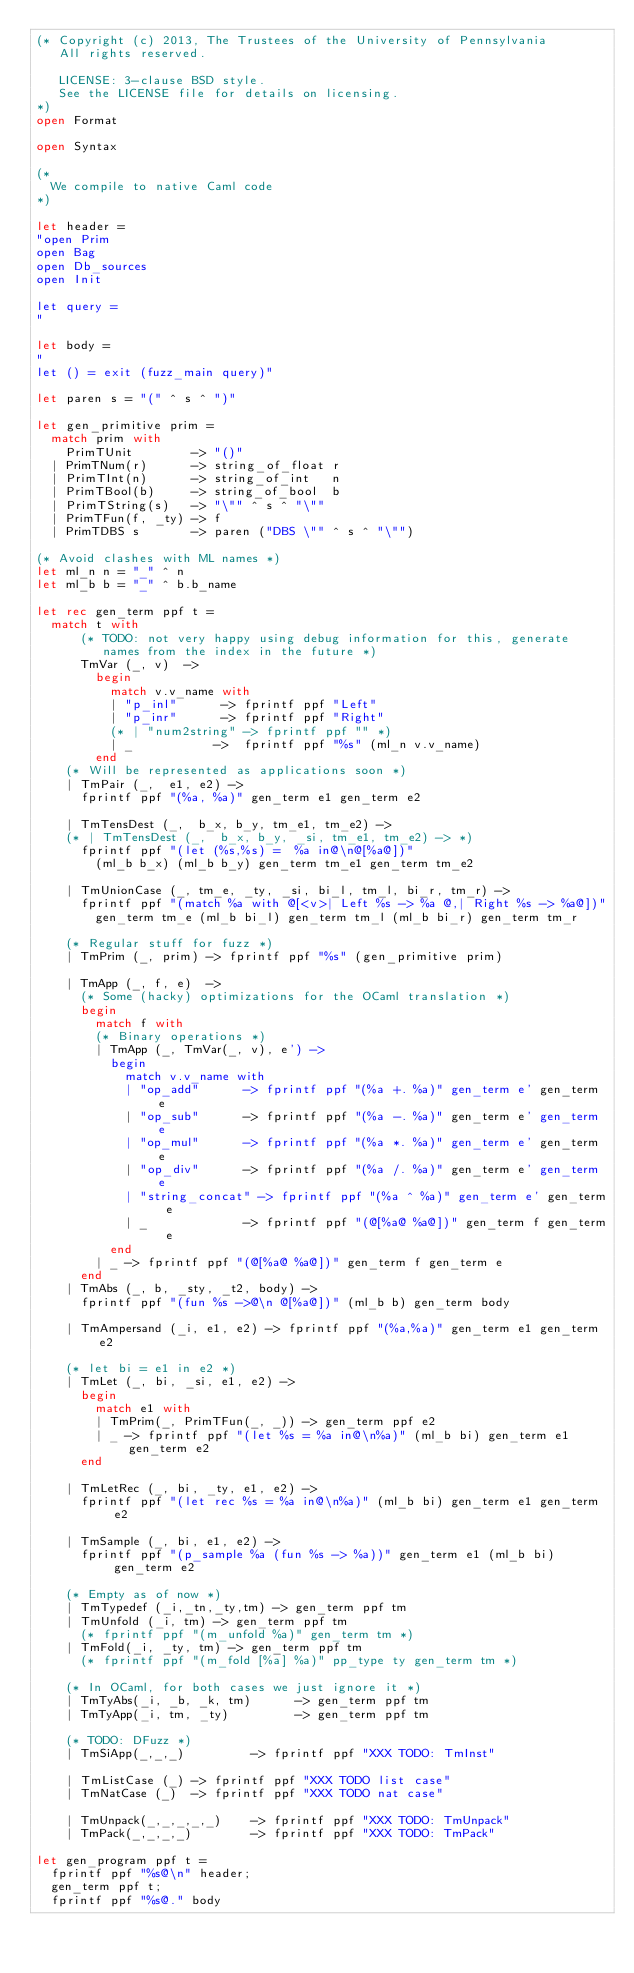<code> <loc_0><loc_0><loc_500><loc_500><_OCaml_>(* Copyright (c) 2013, The Trustees of the University of Pennsylvania
   All rights reserved.

   LICENSE: 3-clause BSD style.
   See the LICENSE file for details on licensing.
*)
open Format

open Syntax

(*
  We compile to native Caml code
*)

let header =
"open Prim
open Bag
open Db_sources
open Init

let query =
"

let body =
"
let () = exit (fuzz_main query)"

let paren s = "(" ^ s ^ ")"

let gen_primitive prim =
  match prim with
    PrimTUnit        -> "()"
  | PrimTNum(r)      -> string_of_float r
  | PrimTInt(n)      -> string_of_int   n
  | PrimTBool(b)     -> string_of_bool  b
  | PrimTString(s)   -> "\"" ^ s ^ "\""
  | PrimTFun(f, _ty) -> f
  | PrimTDBS s       -> paren ("DBS \"" ^ s ^ "\"")

(* Avoid clashes with ML names *)
let ml_n n = "_" ^ n
let ml_b b = "_" ^ b.b_name

let rec gen_term ppf t =
  match t with
      (* TODO: not very happy using debug information for this, generate
         names from the index in the future *)
      TmVar (_, v)  ->
        begin
          match v.v_name with
          | "p_inl"      -> fprintf ppf "Left"
          | "p_inr"      -> fprintf ppf "Right"
          (* | "num2string" -> fprintf ppf "" *)
          | _           ->  fprintf ppf "%s" (ml_n v.v_name)
        end
    (* Will be represented as applications soon *)
    | TmPair (_,  e1, e2) ->
      fprintf ppf "(%a, %a)" gen_term e1 gen_term e2

    | TmTensDest (_,  b_x, b_y, tm_e1, tm_e2) ->
    (* | TmTensDest (_,  b_x, b_y, _si, tm_e1, tm_e2) -> *)
      fprintf ppf "(let (%s,%s) =  %a in@\n@[%a@])"
        (ml_b b_x) (ml_b b_y) gen_term tm_e1 gen_term tm_e2

    | TmUnionCase (_, tm_e, _ty, _si, bi_l, tm_l, bi_r, tm_r) ->
      fprintf ppf "(match %a with @[<v>| Left %s -> %a @,| Right %s -> %a@])"
        gen_term tm_e (ml_b bi_l) gen_term tm_l (ml_b bi_r) gen_term tm_r

    (* Regular stuff for fuzz *)
    | TmPrim (_, prim) -> fprintf ppf "%s" (gen_primitive prim)

    | TmApp (_, f, e)  ->
      (* Some (hacky) optimizations for the OCaml translation *)
      begin
        match f with
        (* Binary operations *)
        | TmApp (_, TmVar(_, v), e') ->
          begin
            match v.v_name with
            | "op_add"      -> fprintf ppf "(%a +. %a)" gen_term e' gen_term e
            | "op_sub"      -> fprintf ppf "(%a -. %a)" gen_term e' gen_term e
            | "op_mul"      -> fprintf ppf "(%a *. %a)" gen_term e' gen_term e
            | "op_div"      -> fprintf ppf "(%a /. %a)" gen_term e' gen_term e
            | "string_concat" -> fprintf ppf "(%a ^ %a)" gen_term e' gen_term e
            | _             -> fprintf ppf "(@[%a@ %a@])" gen_term f gen_term e
          end
        | _ -> fprintf ppf "(@[%a@ %a@])" gen_term f gen_term e
      end
    | TmAbs (_, b, _sty, _t2, body) ->
      fprintf ppf "(fun %s ->@\n @[%a@])" (ml_b b) gen_term body

    | TmAmpersand (_i, e1, e2) -> fprintf ppf "(%a,%a)" gen_term e1 gen_term e2

    (* let bi = e1 in e2 *)
    | TmLet (_, bi, _si, e1, e2) ->
      begin
        match e1 with
        | TmPrim(_, PrimTFun(_, _)) -> gen_term ppf e2
        | _ -> fprintf ppf "(let %s = %a in@\n%a)" (ml_b bi) gen_term e1 gen_term e2
      end

    | TmLetRec (_, bi, _ty, e1, e2) ->
      fprintf ppf "(let rec %s = %a in@\n%a)" (ml_b bi) gen_term e1 gen_term e2

    | TmSample (_, bi, e1, e2) ->
      fprintf ppf "(p_sample %a (fun %s -> %a))" gen_term e1 (ml_b bi) gen_term e2

    (* Empty as of now *)
    | TmTypedef (_i,_tn,_ty,tm) -> gen_term ppf tm
    | TmUnfold (_i, tm) -> gen_term ppf tm
      (* fprintf ppf "(m_unfold %a)" gen_term tm *)
    | TmFold(_i, _ty, tm) -> gen_term ppf tm
      (* fprintf ppf "(m_fold [%a] %a)" pp_type ty gen_term tm *)

    (* In OCaml, for both cases we just ignore it *)
    | TmTyAbs(_i, _b, _k, tm)      -> gen_term ppf tm
    | TmTyApp(_i, tm, _ty)         -> gen_term ppf tm

    (* TODO: DFuzz *)
    | TmSiApp(_,_,_)         -> fprintf ppf "XXX TODO: TmInst"

    | TmListCase (_) -> fprintf ppf "XXX TODO list case"
    | TmNatCase (_)  -> fprintf ppf "XXX TODO nat case"

    | TmUnpack(_,_,_,_,_)    -> fprintf ppf "XXX TODO: TmUnpack"
    | TmPack(_,_,_,_)        -> fprintf ppf "XXX TODO: TmPack"

let gen_program ppf t =
  fprintf ppf "%s@\n" header;
  gen_term ppf t;
  fprintf ppf "%s@." body
</code> 